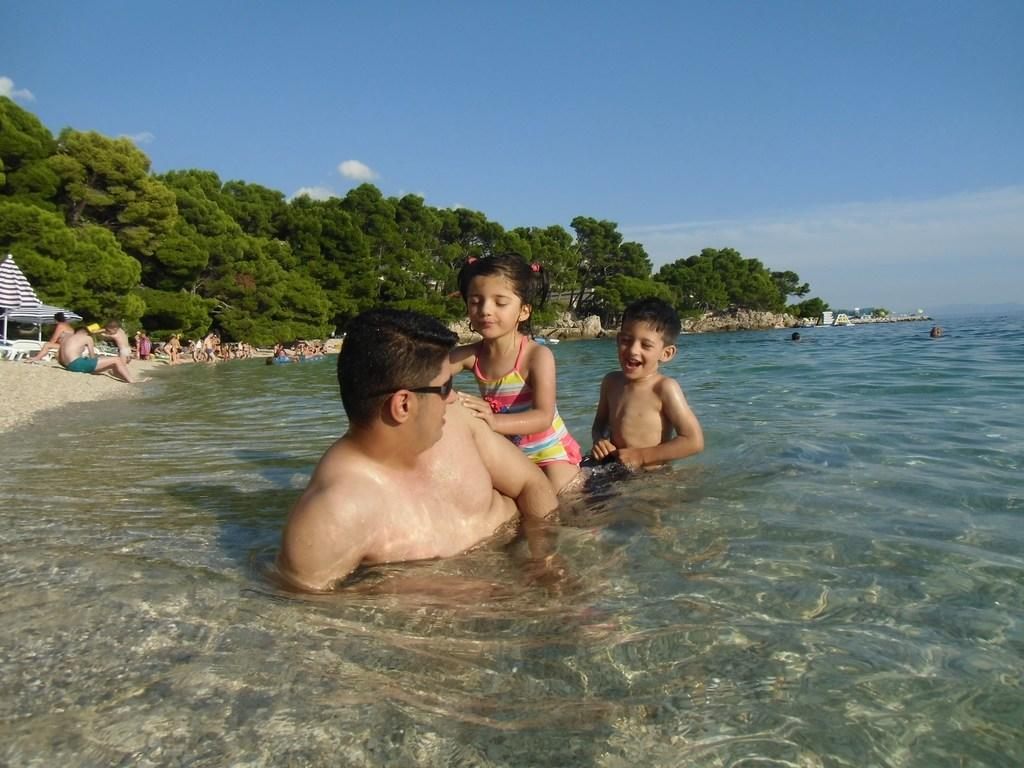Who is present in the image besides the kids? There is a man in the image. What are the man and kids doing in the image? The man and kids are in the water. What else can be seen in the image? There are people sitting at the seashore and green trees visible in the image. What is the color of the sky in the image? The sky is blue at the top of the image. Can you see any veins in the image? There are no veins visible in the image; it features people in the water and a seashore setting. What type of sticks are the kids using to play with in the image? There are no sticks present in the image; the kids are in the water with the man. 